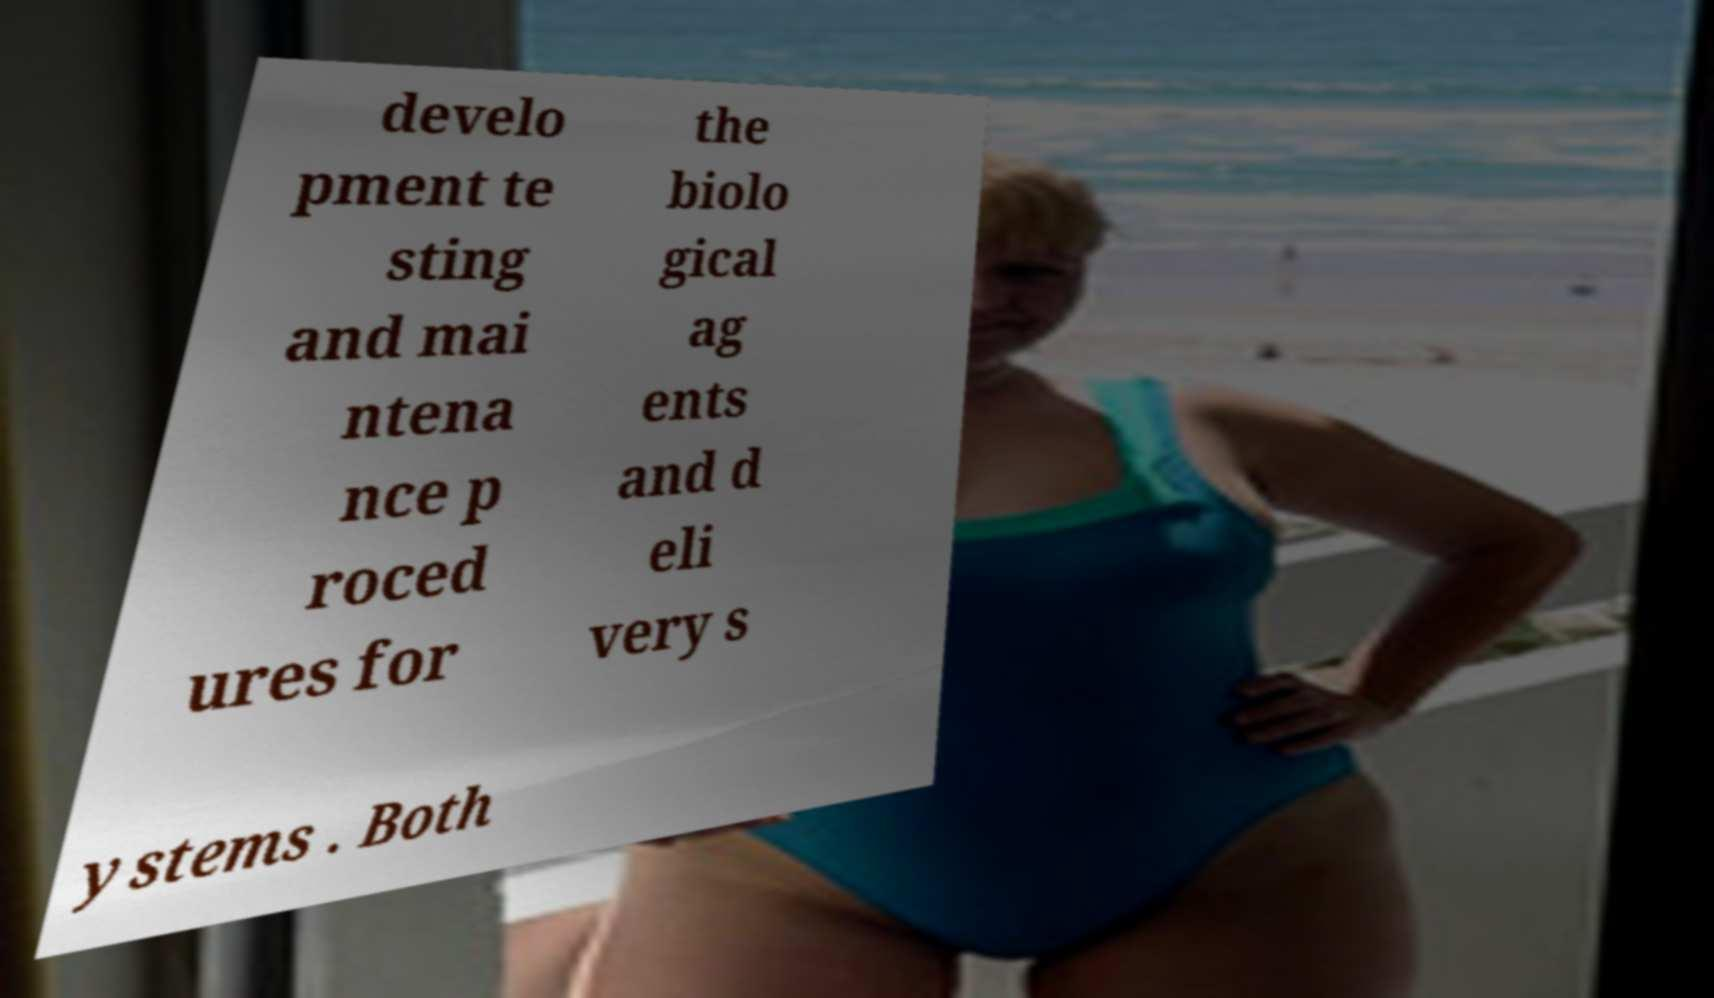I need the written content from this picture converted into text. Can you do that? develo pment te sting and mai ntena nce p roced ures for the biolo gical ag ents and d eli very s ystems . Both 